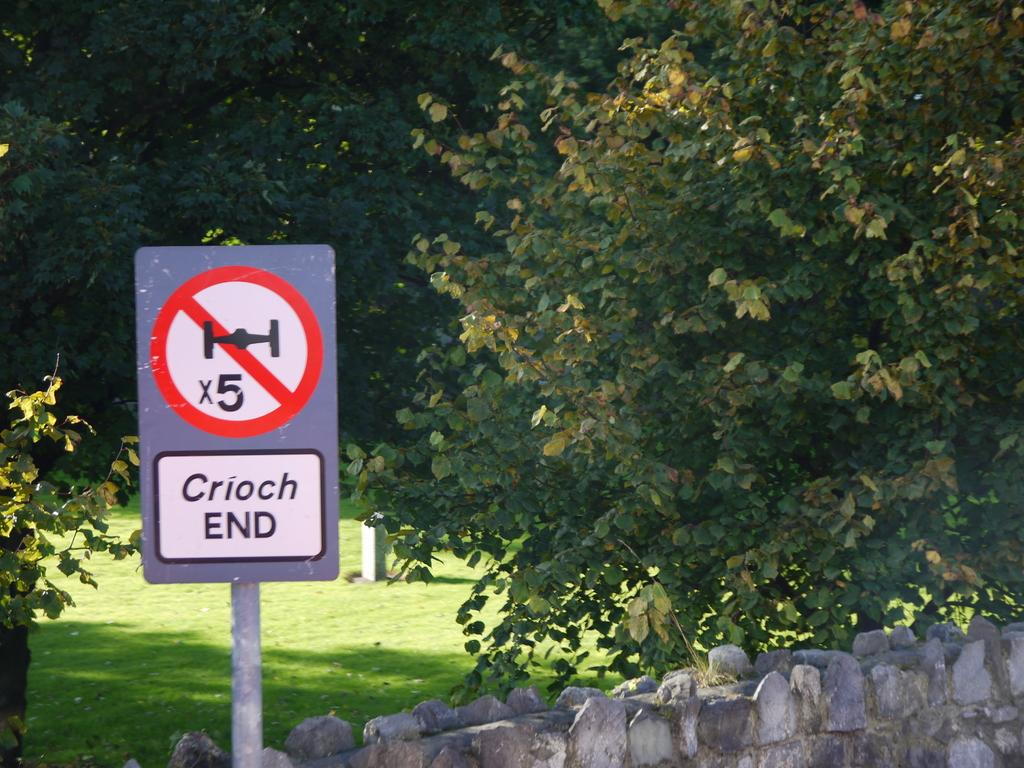<image>
Create a compact narrative representing the image presented. A sign next to a stone wall indicates Crioch End. 